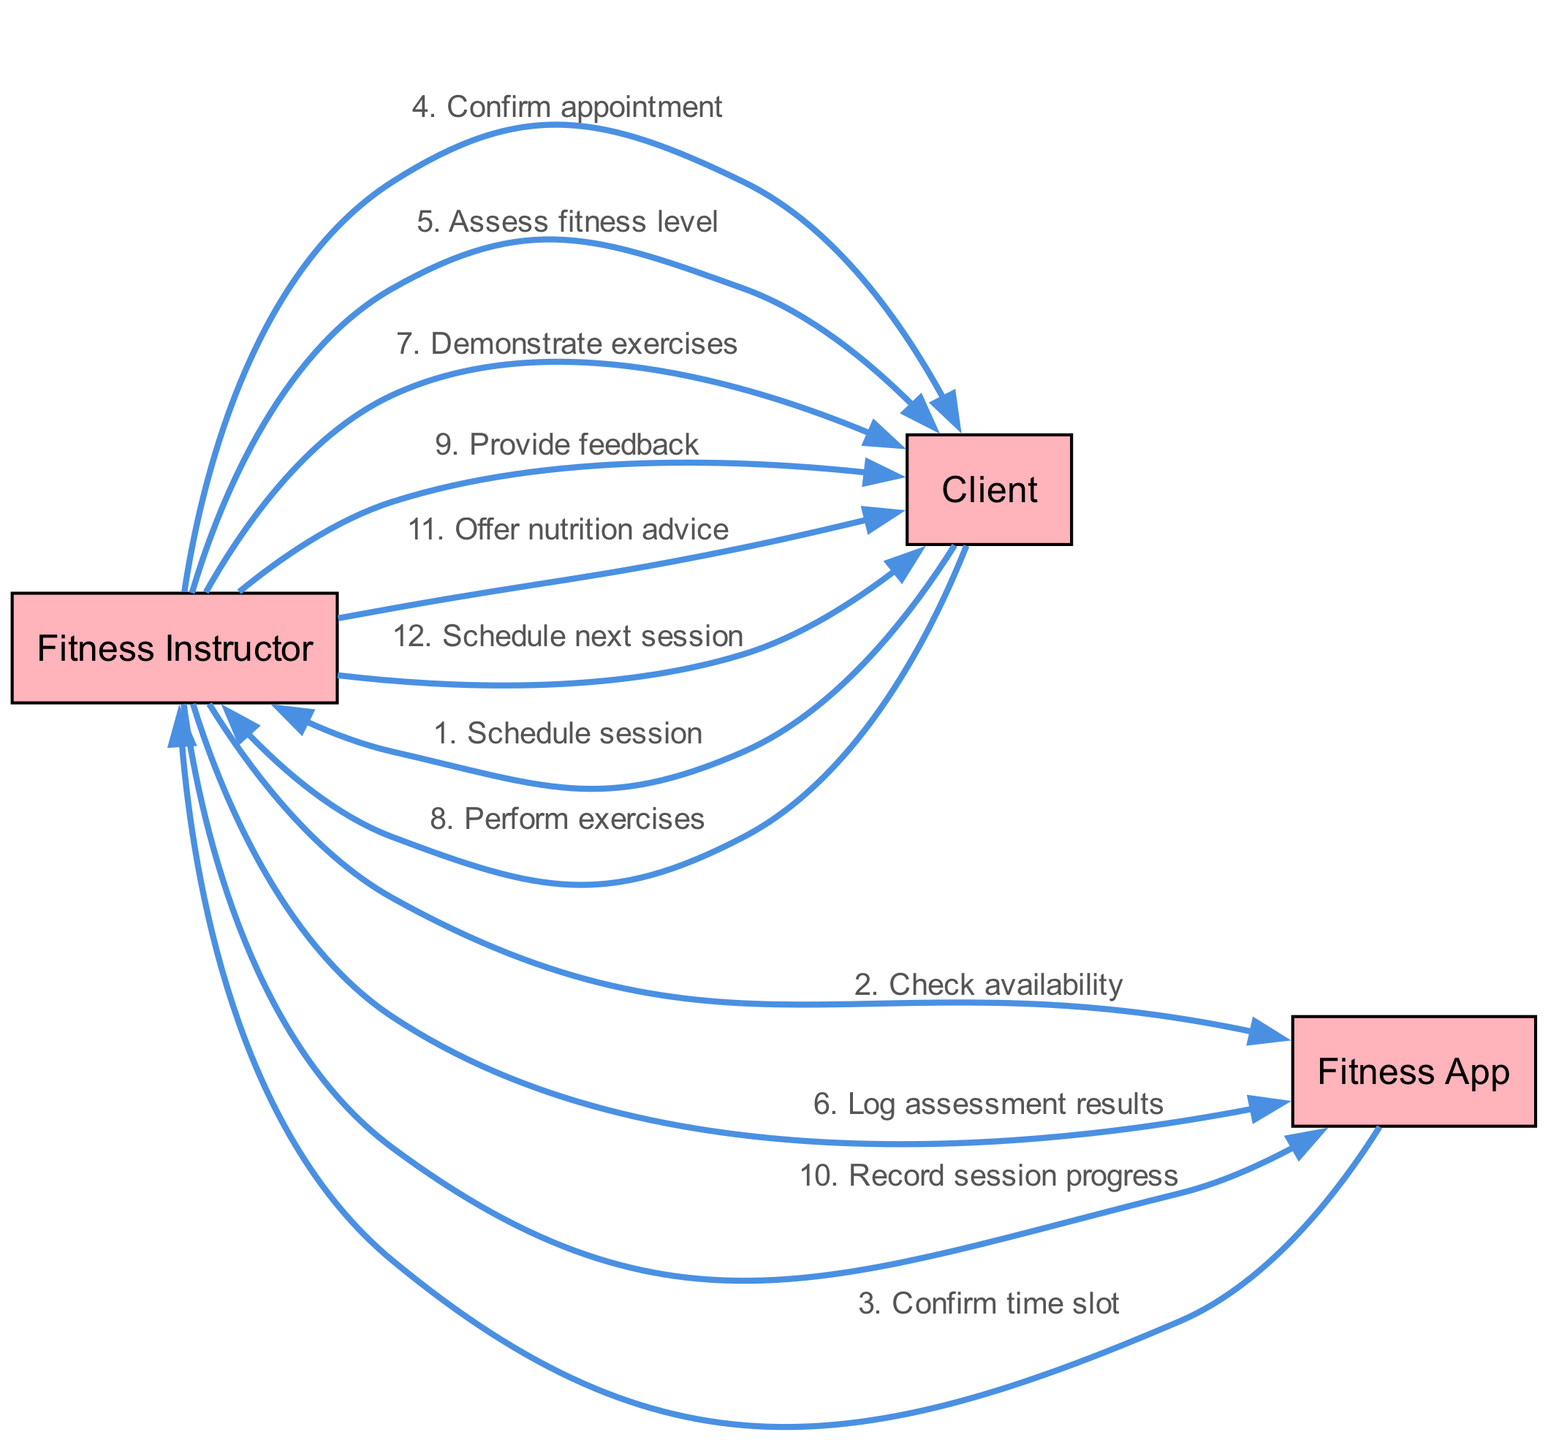What is the first action taken by the Client? The Client's first action is to schedule a session with the Fitness Instructor, as represented by the first message in the sequence.
Answer: Schedule session How many actors are involved in this diagram? The diagram includes three actors: Fitness Instructor, Client, and Fitness App, which are clearly labeled and depicted in the diagram.
Answer: 3 What message follows the "Check availability" action? After the Fitness Instructor checks availability, the next action is the Fitness App confirming the time slot, which is the message that follows.
Answer: Confirm time slot Who provides feedback to the Client? The feedback is given to the Client by the Fitness Instructor, as indicated by the message directed from the Fitness Instructor to the Client.
Answer: Fitness Instructor What task does the Fitness Instructor perform after assessing the fitness level? After assessing the fitness level, the instructor demonstrates exercises to the Client, as shown in the sequence that follows the assessment message.
Answer: Demonstrate exercises In what order does the Client perform exercises? The Client performs exercises after the Fitness Instructor demonstrates them, as represented by the messages in sequential order in the diagram.
Answer: After demonstrating exercises What is the last action depicted in the sequence? The last action shown in the sequence is the Fitness Instructor scheduling the next session with the Client, marking the completion of the sequence.
Answer: Schedule next session How many messages are exchanged between Fitness Instructor and Client? There are six messages exchanged between the Fitness Instructor and Client throughout the entire sequence, demonstrating interactions such as assessments, feedback, and scheduling.
Answer: 6 What does the Fitness Instructor do with the assessment results? The Fitness Instructor logs the assessment results into the Fitness App, as stated in the sequence following the assessment.
Answer: Log assessment results 